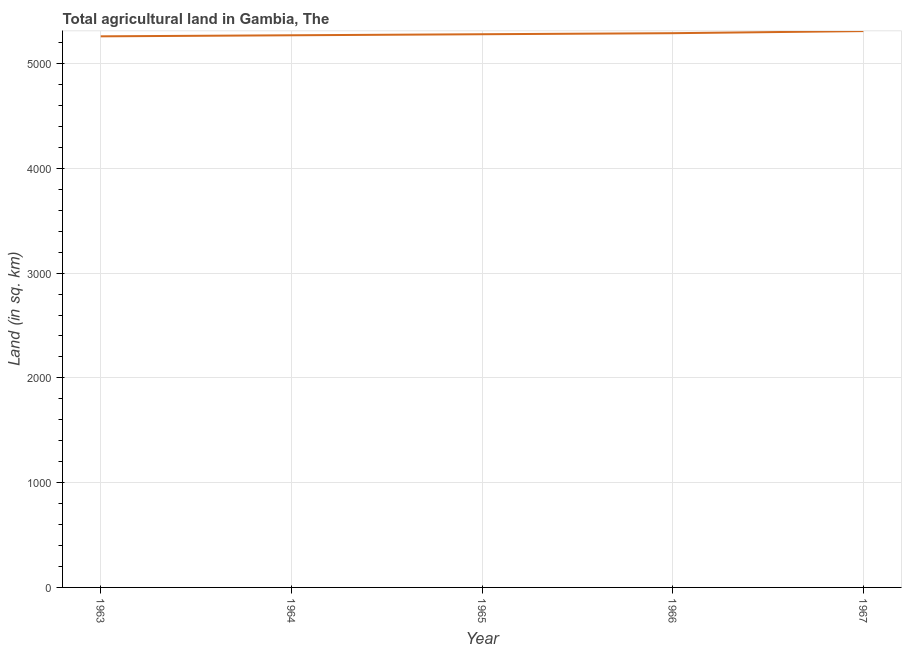What is the agricultural land in 1967?
Offer a terse response. 5310. Across all years, what is the maximum agricultural land?
Offer a very short reply. 5310. Across all years, what is the minimum agricultural land?
Offer a very short reply. 5260. In which year was the agricultural land maximum?
Provide a succinct answer. 1967. What is the sum of the agricultural land?
Offer a very short reply. 2.64e+04. What is the difference between the agricultural land in 1963 and 1965?
Give a very brief answer. -20. What is the average agricultural land per year?
Ensure brevity in your answer.  5282. What is the median agricultural land?
Offer a terse response. 5280. What is the ratio of the agricultural land in 1963 to that in 1966?
Ensure brevity in your answer.  0.99. Is the difference between the agricultural land in 1964 and 1966 greater than the difference between any two years?
Your response must be concise. No. What is the difference between the highest and the lowest agricultural land?
Keep it short and to the point. 50. Does the agricultural land monotonically increase over the years?
Provide a succinct answer. Yes. What is the difference between two consecutive major ticks on the Y-axis?
Your response must be concise. 1000. Are the values on the major ticks of Y-axis written in scientific E-notation?
Offer a terse response. No. Does the graph contain any zero values?
Ensure brevity in your answer.  No. What is the title of the graph?
Give a very brief answer. Total agricultural land in Gambia, The. What is the label or title of the X-axis?
Offer a terse response. Year. What is the label or title of the Y-axis?
Make the answer very short. Land (in sq. km). What is the Land (in sq. km) of 1963?
Offer a terse response. 5260. What is the Land (in sq. km) of 1964?
Offer a very short reply. 5270. What is the Land (in sq. km) of 1965?
Offer a terse response. 5280. What is the Land (in sq. km) in 1966?
Your answer should be compact. 5290. What is the Land (in sq. km) in 1967?
Your response must be concise. 5310. What is the difference between the Land (in sq. km) in 1963 and 1966?
Give a very brief answer. -30. What is the difference between the Land (in sq. km) in 1963 and 1967?
Offer a very short reply. -50. What is the difference between the Land (in sq. km) in 1964 and 1965?
Give a very brief answer. -10. What is the difference between the Land (in sq. km) in 1964 and 1966?
Provide a short and direct response. -20. What is the difference between the Land (in sq. km) in 1964 and 1967?
Provide a short and direct response. -40. What is the difference between the Land (in sq. km) in 1965 and 1966?
Give a very brief answer. -10. What is the difference between the Land (in sq. km) in 1965 and 1967?
Give a very brief answer. -30. What is the ratio of the Land (in sq. km) in 1963 to that in 1966?
Provide a short and direct response. 0.99. What is the ratio of the Land (in sq. km) in 1963 to that in 1967?
Ensure brevity in your answer.  0.99. What is the ratio of the Land (in sq. km) in 1964 to that in 1965?
Your answer should be very brief. 1. What is the ratio of the Land (in sq. km) in 1964 to that in 1966?
Ensure brevity in your answer.  1. What is the ratio of the Land (in sq. km) in 1964 to that in 1967?
Your answer should be very brief. 0.99. 